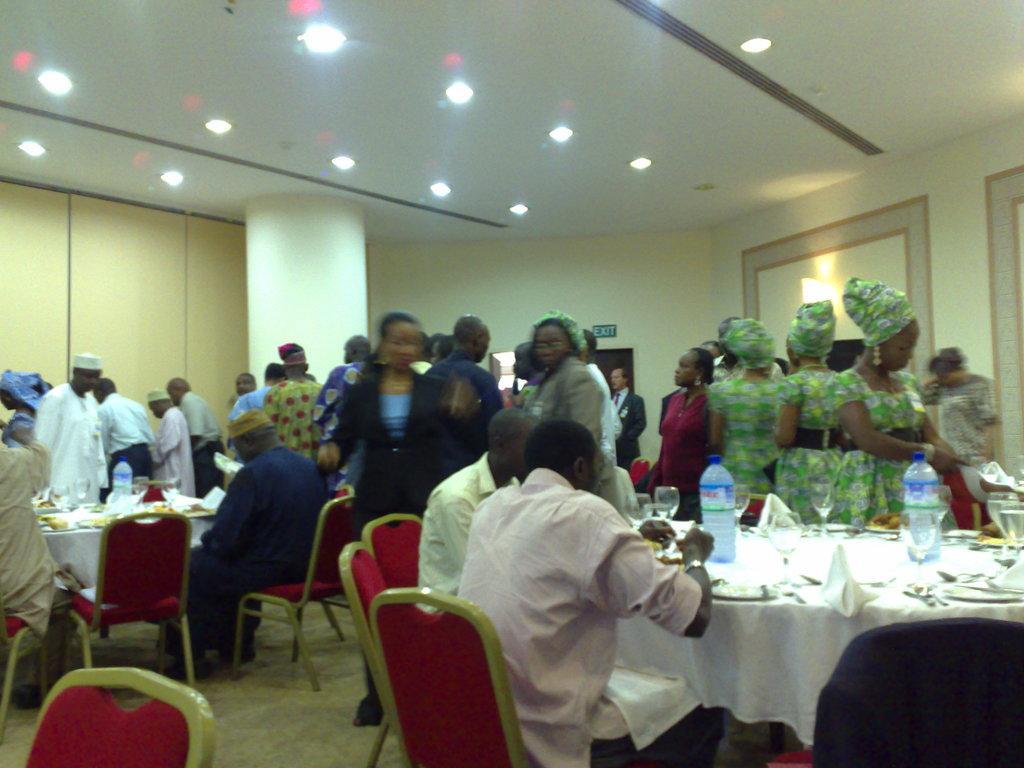How would you summarize this image in a sentence or two? In this image I can see the group of people. Among them some people are sitting and some are standing. In front of the sitting people there is a table. On the table there are plates and the bottles. 